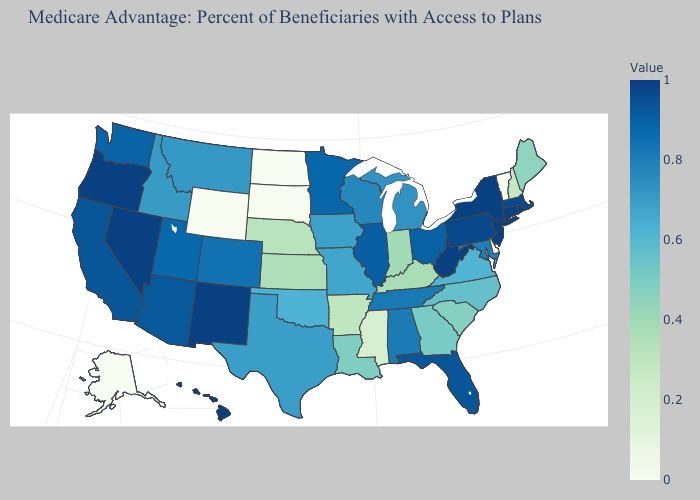Among the states that border Arkansas , which have the lowest value?
Concise answer only. Mississippi. Which states have the highest value in the USA?
Short answer required. Connecticut, New Jersey, New Mexico, Nevada, Oregon, Rhode Island, West Virginia. 